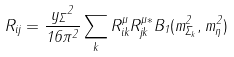Convert formula to latex. <formula><loc_0><loc_0><loc_500><loc_500>R _ { i j } = \frac { { y _ { \Sigma } } ^ { 2 } } { 1 6 \pi ^ { 2 } } \sum _ { k } R ^ { \mu } _ { i k } R ^ { \mu * } _ { j k } B _ { 1 } ( m _ { \Sigma _ { k } } ^ { 2 } , m _ { \eta } ^ { 2 } )</formula> 